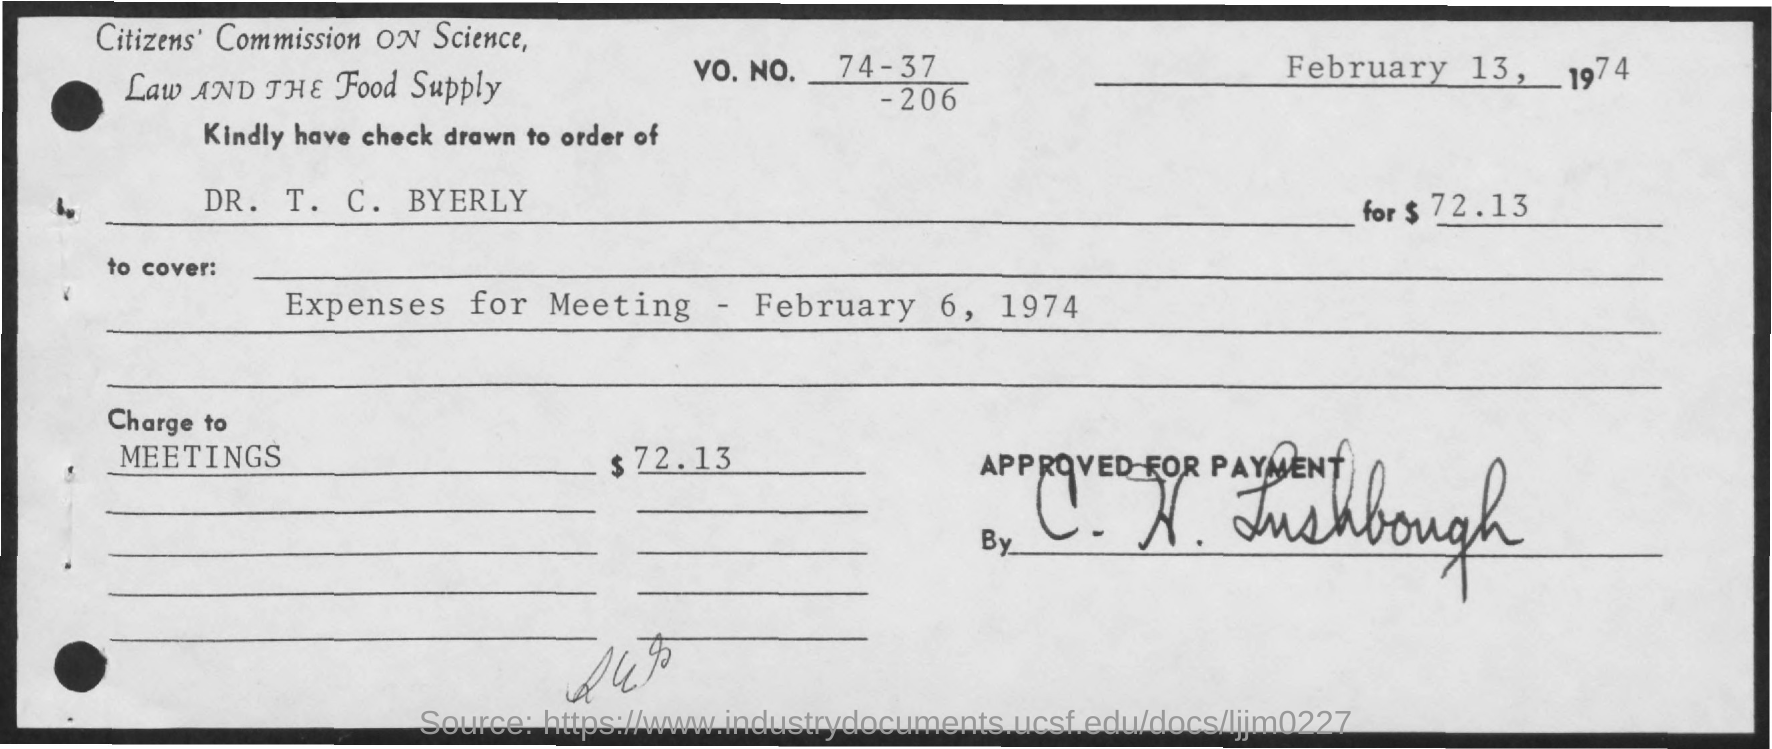List a handful of essential elements in this visual. This check covers the expenses incurred for the meeting that took place on February 6, 1974. The check is issued in the name of DR. T. C. BYERLY. The date of February 13, 1974, is the check date. The Vo. No. mentioned in the check is 74-37. The amount of the check is $72.13. 